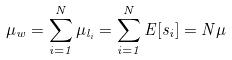Convert formula to latex. <formula><loc_0><loc_0><loc_500><loc_500>\mu _ { w } = \sum _ { i = 1 } ^ { N } \mu _ { l _ { i } } = \sum _ { i = 1 } ^ { N } E [ s _ { i } ] = N \mu</formula> 